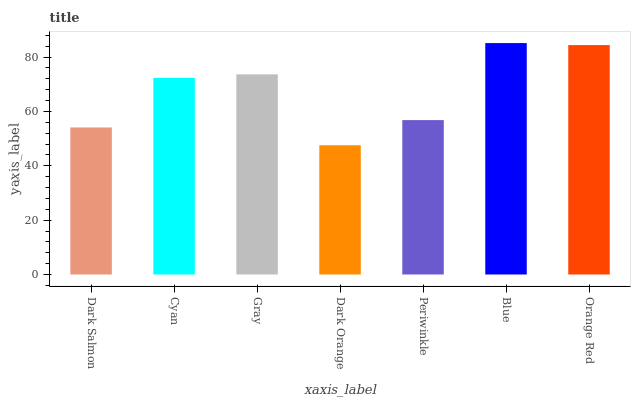Is Dark Orange the minimum?
Answer yes or no. Yes. Is Blue the maximum?
Answer yes or no. Yes. Is Cyan the minimum?
Answer yes or no. No. Is Cyan the maximum?
Answer yes or no. No. Is Cyan greater than Dark Salmon?
Answer yes or no. Yes. Is Dark Salmon less than Cyan?
Answer yes or no. Yes. Is Dark Salmon greater than Cyan?
Answer yes or no. No. Is Cyan less than Dark Salmon?
Answer yes or no. No. Is Cyan the high median?
Answer yes or no. Yes. Is Cyan the low median?
Answer yes or no. Yes. Is Blue the high median?
Answer yes or no. No. Is Dark Orange the low median?
Answer yes or no. No. 